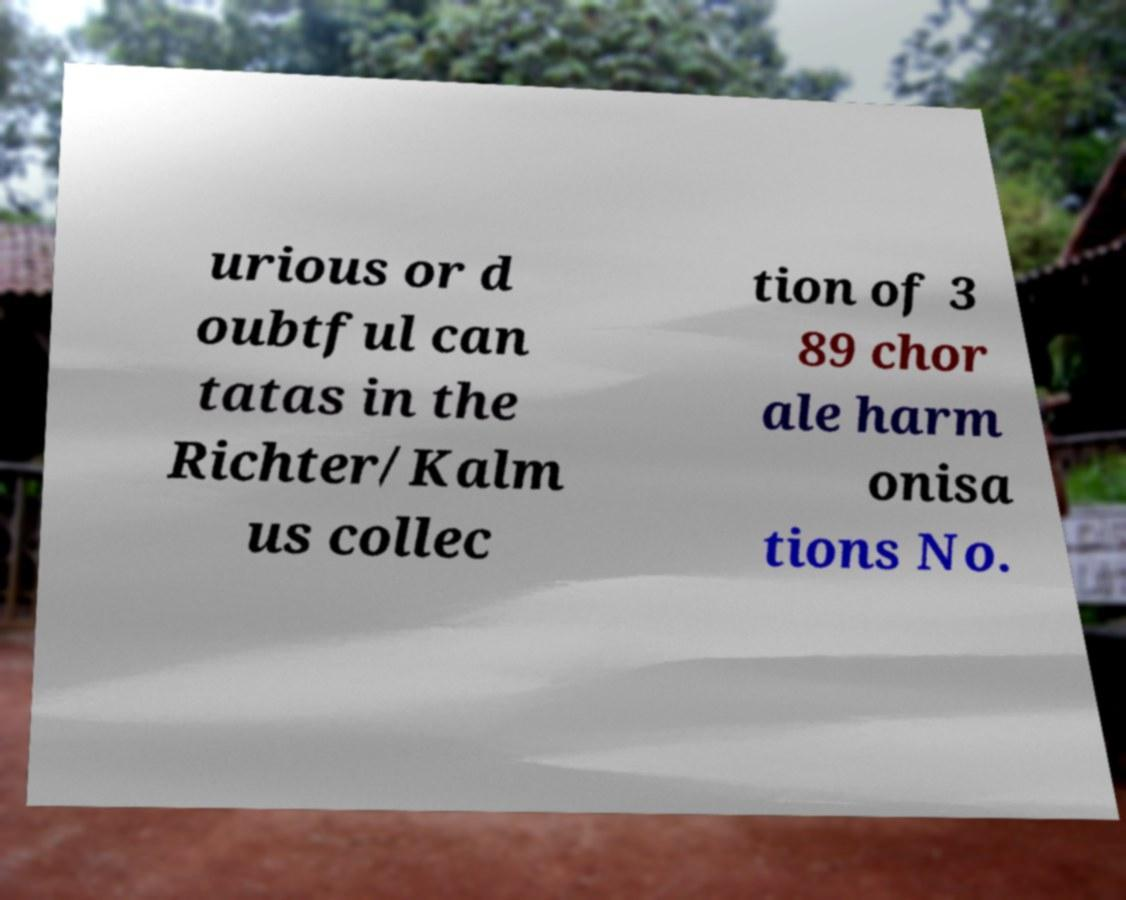Please identify and transcribe the text found in this image. urious or d oubtful can tatas in the Richter/Kalm us collec tion of 3 89 chor ale harm onisa tions No. 